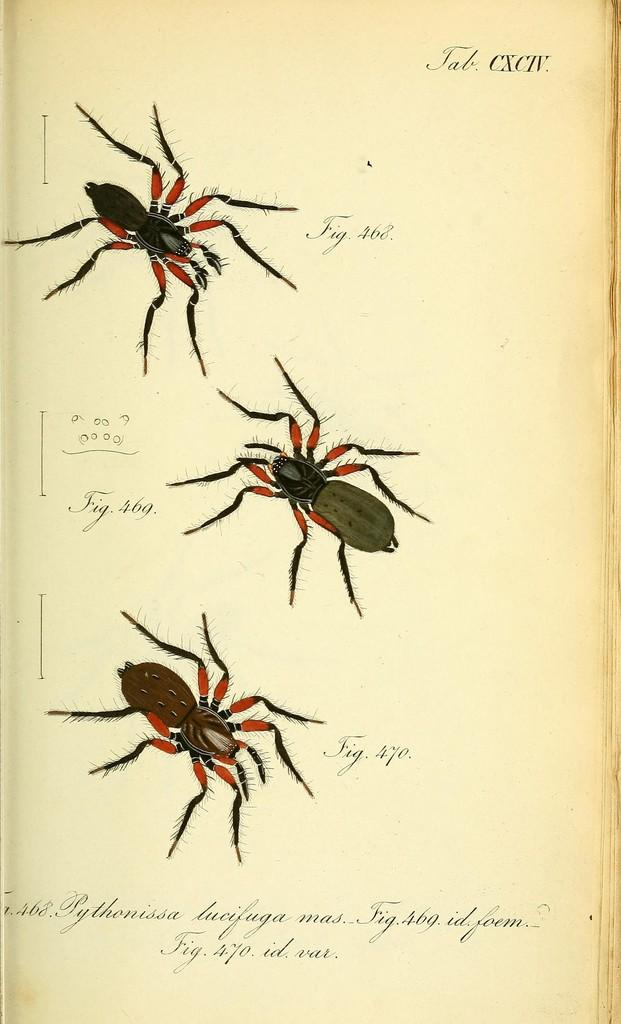What is the main subject of the paper in the image? The paper contains pictures of insects. Is there any text on the paper? Yes, there is text on the paper. What type of skin condition is depicted in the images on the paper? There is no skin condition depicted in the images on the paper; it contains pictures of insects. 